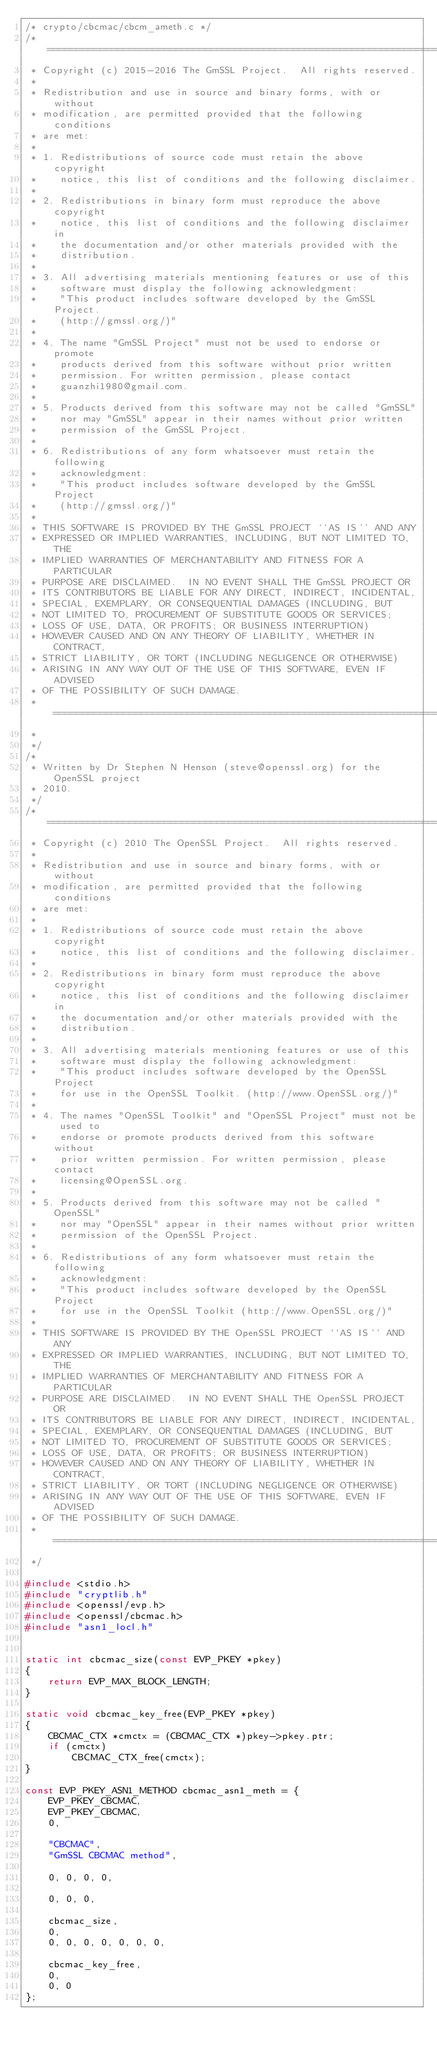Convert code to text. <code><loc_0><loc_0><loc_500><loc_500><_C_>/* crypto/cbcmac/cbcm_ameth.c */
/* ====================================================================
 * Copyright (c) 2015-2016 The GmSSL Project.  All rights reserved.
 *
 * Redistribution and use in source and binary forms, with or without
 * modification, are permitted provided that the following conditions
 * are met:
 *
 * 1. Redistributions of source code must retain the above copyright
 *    notice, this list of conditions and the following disclaimer.
 *
 * 2. Redistributions in binary form must reproduce the above copyright
 *    notice, this list of conditions and the following disclaimer in
 *    the documentation and/or other materials provided with the
 *    distribution.
 *
 * 3. All advertising materials mentioning features or use of this
 *    software must display the following acknowledgment:
 *    "This product includes software developed by the GmSSL Project.
 *    (http://gmssl.org/)"
 *
 * 4. The name "GmSSL Project" must not be used to endorse or promote
 *    products derived from this software without prior written
 *    permission. For written permission, please contact
 *    guanzhi1980@gmail.com.
 *
 * 5. Products derived from this software may not be called "GmSSL"
 *    nor may "GmSSL" appear in their names without prior written
 *    permission of the GmSSL Project.
 *
 * 6. Redistributions of any form whatsoever must retain the following
 *    acknowledgment:
 *    "This product includes software developed by the GmSSL Project
 *    (http://gmssl.org/)"
 *
 * THIS SOFTWARE IS PROVIDED BY THE GmSSL PROJECT ``AS IS'' AND ANY
 * EXPRESSED OR IMPLIED WARRANTIES, INCLUDING, BUT NOT LIMITED TO, THE
 * IMPLIED WARRANTIES OF MERCHANTABILITY AND FITNESS FOR A PARTICULAR
 * PURPOSE ARE DISCLAIMED.  IN NO EVENT SHALL THE GmSSL PROJECT OR
 * ITS CONTRIBUTORS BE LIABLE FOR ANY DIRECT, INDIRECT, INCIDENTAL,
 * SPECIAL, EXEMPLARY, OR CONSEQUENTIAL DAMAGES (INCLUDING, BUT
 * NOT LIMITED TO, PROCUREMENT OF SUBSTITUTE GOODS OR SERVICES;
 * LOSS OF USE, DATA, OR PROFITS; OR BUSINESS INTERRUPTION)
 * HOWEVER CAUSED AND ON ANY THEORY OF LIABILITY, WHETHER IN CONTRACT,
 * STRICT LIABILITY, OR TORT (INCLUDING NEGLIGENCE OR OTHERWISE)
 * ARISING IN ANY WAY OUT OF THE USE OF THIS SOFTWARE, EVEN IF ADVISED
 * OF THE POSSIBILITY OF SUCH DAMAGE.
 * ====================================================================
 *
 */
/*
 * Written by Dr Stephen N Henson (steve@openssl.org) for the OpenSSL project
 * 2010.
 */
/* ====================================================================
 * Copyright (c) 2010 The OpenSSL Project.  All rights reserved.
 *
 * Redistribution and use in source and binary forms, with or without
 * modification, are permitted provided that the following conditions
 * are met:
 *
 * 1. Redistributions of source code must retain the above copyright
 *    notice, this list of conditions and the following disclaimer.
 *
 * 2. Redistributions in binary form must reproduce the above copyright
 *    notice, this list of conditions and the following disclaimer in
 *    the documentation and/or other materials provided with the
 *    distribution.
 *
 * 3. All advertising materials mentioning features or use of this
 *    software must display the following acknowledgment:
 *    "This product includes software developed by the OpenSSL Project
 *    for use in the OpenSSL Toolkit. (http://www.OpenSSL.org/)"
 *
 * 4. The names "OpenSSL Toolkit" and "OpenSSL Project" must not be used to
 *    endorse or promote products derived from this software without
 *    prior written permission. For written permission, please contact
 *    licensing@OpenSSL.org.
 *
 * 5. Products derived from this software may not be called "OpenSSL"
 *    nor may "OpenSSL" appear in their names without prior written
 *    permission of the OpenSSL Project.
 *
 * 6. Redistributions of any form whatsoever must retain the following
 *    acknowledgment:
 *    "This product includes software developed by the OpenSSL Project
 *    for use in the OpenSSL Toolkit (http://www.OpenSSL.org/)"
 *
 * THIS SOFTWARE IS PROVIDED BY THE OpenSSL PROJECT ``AS IS'' AND ANY
 * EXPRESSED OR IMPLIED WARRANTIES, INCLUDING, BUT NOT LIMITED TO, THE
 * IMPLIED WARRANTIES OF MERCHANTABILITY AND FITNESS FOR A PARTICULAR
 * PURPOSE ARE DISCLAIMED.  IN NO EVENT SHALL THE OpenSSL PROJECT OR
 * ITS CONTRIBUTORS BE LIABLE FOR ANY DIRECT, INDIRECT, INCIDENTAL,
 * SPECIAL, EXEMPLARY, OR CONSEQUENTIAL DAMAGES (INCLUDING, BUT
 * NOT LIMITED TO, PROCUREMENT OF SUBSTITUTE GOODS OR SERVICES;
 * LOSS OF USE, DATA, OR PROFITS; OR BUSINESS INTERRUPTION)
 * HOWEVER CAUSED AND ON ANY THEORY OF LIABILITY, WHETHER IN CONTRACT,
 * STRICT LIABILITY, OR TORT (INCLUDING NEGLIGENCE OR OTHERWISE)
 * ARISING IN ANY WAY OUT OF THE USE OF THIS SOFTWARE, EVEN IF ADVISED
 * OF THE POSSIBILITY OF SUCH DAMAGE.
 * ====================================================================
 */

#include <stdio.h>
#include "cryptlib.h"
#include <openssl/evp.h>
#include <openssl/cbcmac.h>
#include "asn1_locl.h"


static int cbcmac_size(const EVP_PKEY *pkey)
{
    return EVP_MAX_BLOCK_LENGTH;
}

static void cbcmac_key_free(EVP_PKEY *pkey)
{
    CBCMAC_CTX *cmctx = (CBCMAC_CTX *)pkey->pkey.ptr;
    if (cmctx)
        CBCMAC_CTX_free(cmctx);
}

const EVP_PKEY_ASN1_METHOD cbcmac_asn1_meth = {
    EVP_PKEY_CBCMAC,
    EVP_PKEY_CBCMAC,
    0,

    "CBCMAC",
    "GmSSL CBCMAC method",

    0, 0, 0, 0,

    0, 0, 0,

    cbcmac_size,
    0,
    0, 0, 0, 0, 0, 0, 0,

    cbcmac_key_free,
    0,
    0, 0
};
</code> 